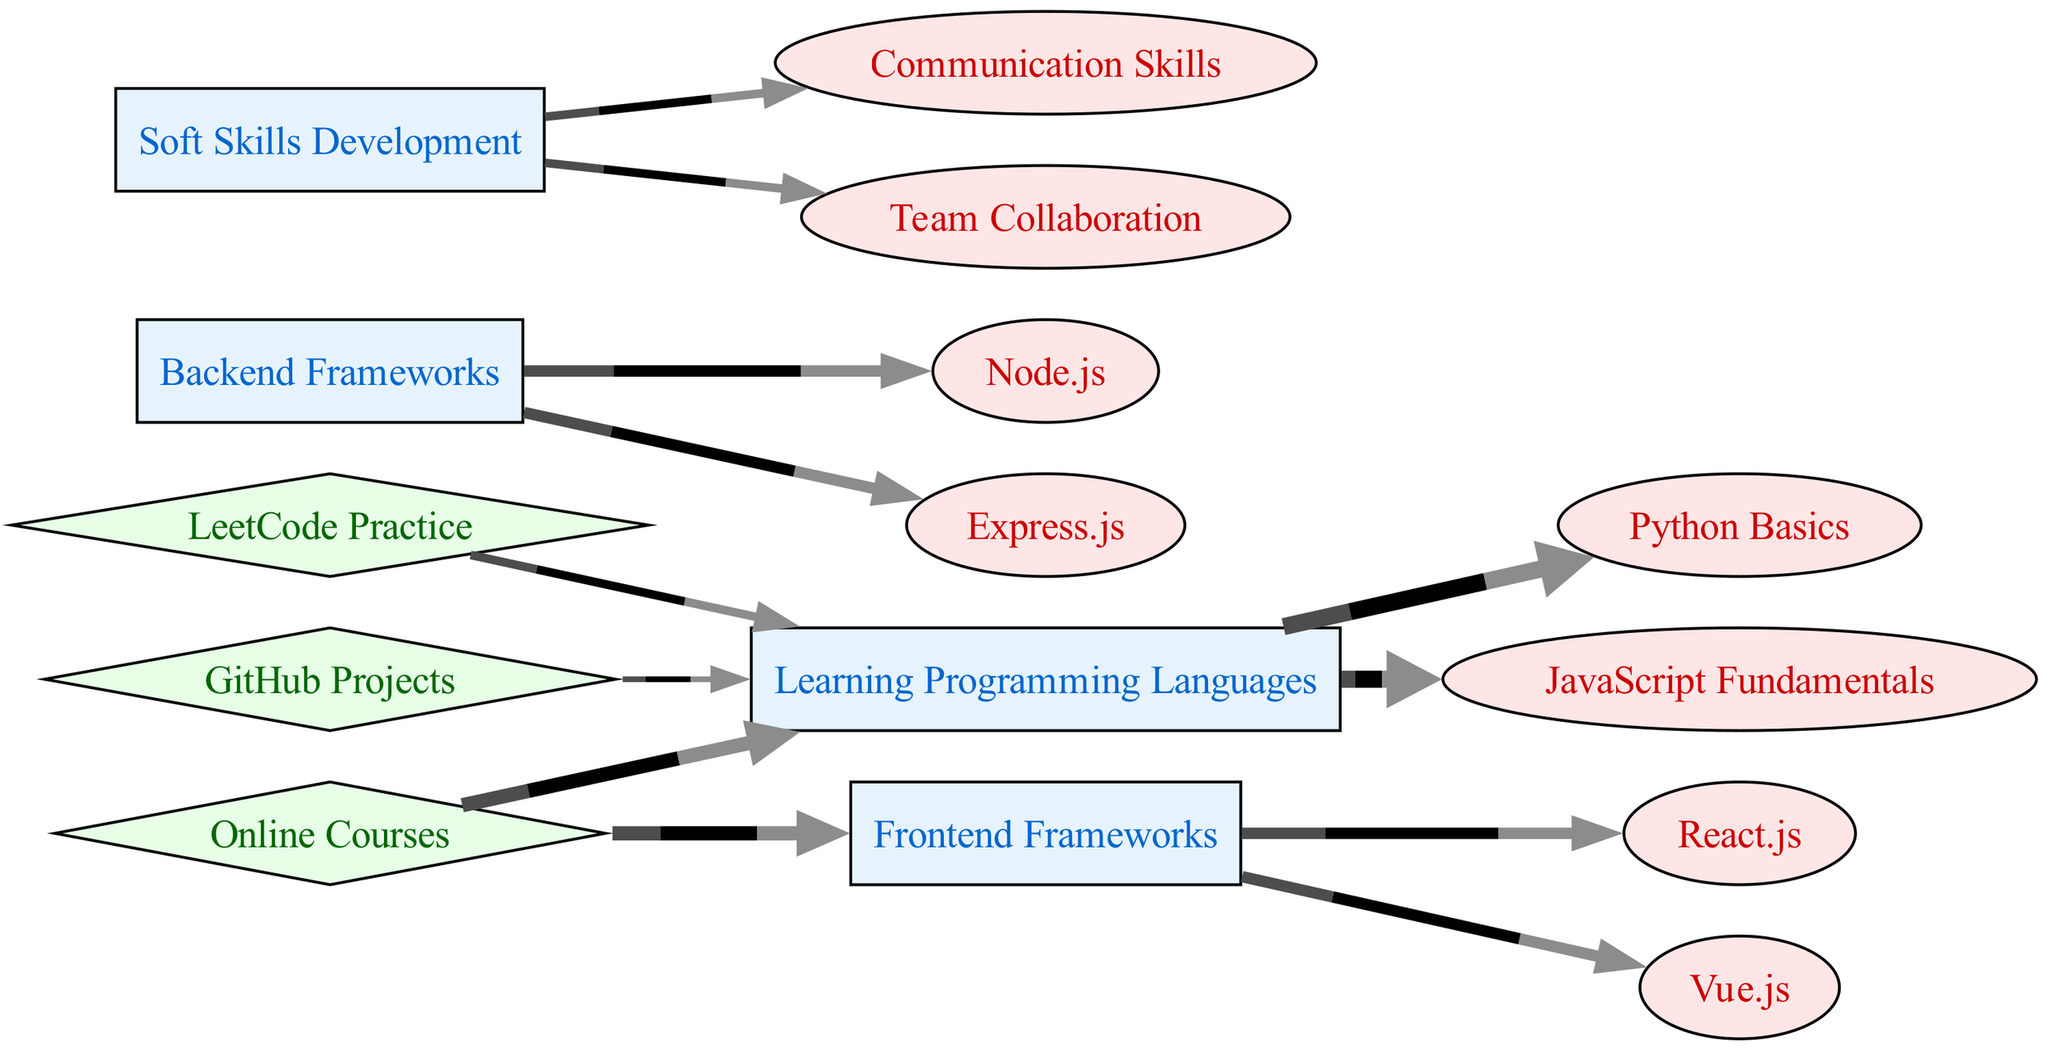What are the two primary areas of focus for skills development? The diagram indicates that the two primary areas of focus for skills development are "Learning Programming Languages" and "Soft Skills Development", both marked as activities.
Answer: Learning Programming Languages, Soft Skills Development How many skills are associated with frontend frameworks? By examining the links from "Frontend Frameworks", there are two associated skills: "React.js" and "Vue.js".
Answer: 2 What is the value assigned to practicing with LeetCode? According to the flow in the diagram, the value assigned to practicing with LeetCode under resources linked to "Learning Programming Languages" is 15.
Answer: 15 Which skill has a direct link to both backend frameworks? The skills "Node.js" and "Express.js" both have a direct link from "Backend Frameworks".
Answer: Node.js, Express.js Which learning resource has the highest total value directed towards programming language learning? The highest total value for resources directed towards "Learning Programming Languages" is from "Online Courses" with a value of 25.
Answer: Online Courses What is the total amount of time invested in developing soft skills? For "Soft Skills Development", both "Communication Skills" and "Team Collaboration" have a value of 15 each, summing up to a total of 30.
Answer: 30 How many activities are shown in the diagram? The activities listed in the diagram are "Learning Programming Languages", "Frontend Frameworks", "Backend Frameworks", and "Soft Skills Development", resulting in a total of four activities.
Answer: 4 What programming language skills have equal time investment? Both "Python Basics" and "JavaScript Fundamentals" are assigned an equal value of 30.
Answer: Python Basics, JavaScript Fundamentals 